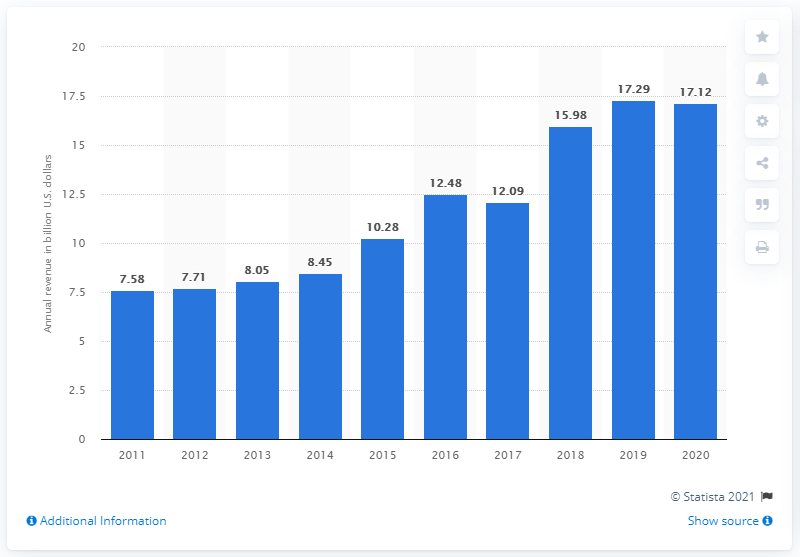Point out several critical features in this image. In the previous year, Becton, Dickinson, and Company generated revenue of 15.98. Becton, Dickinson, and Company reported a revenue of 17.29 in 2019. 